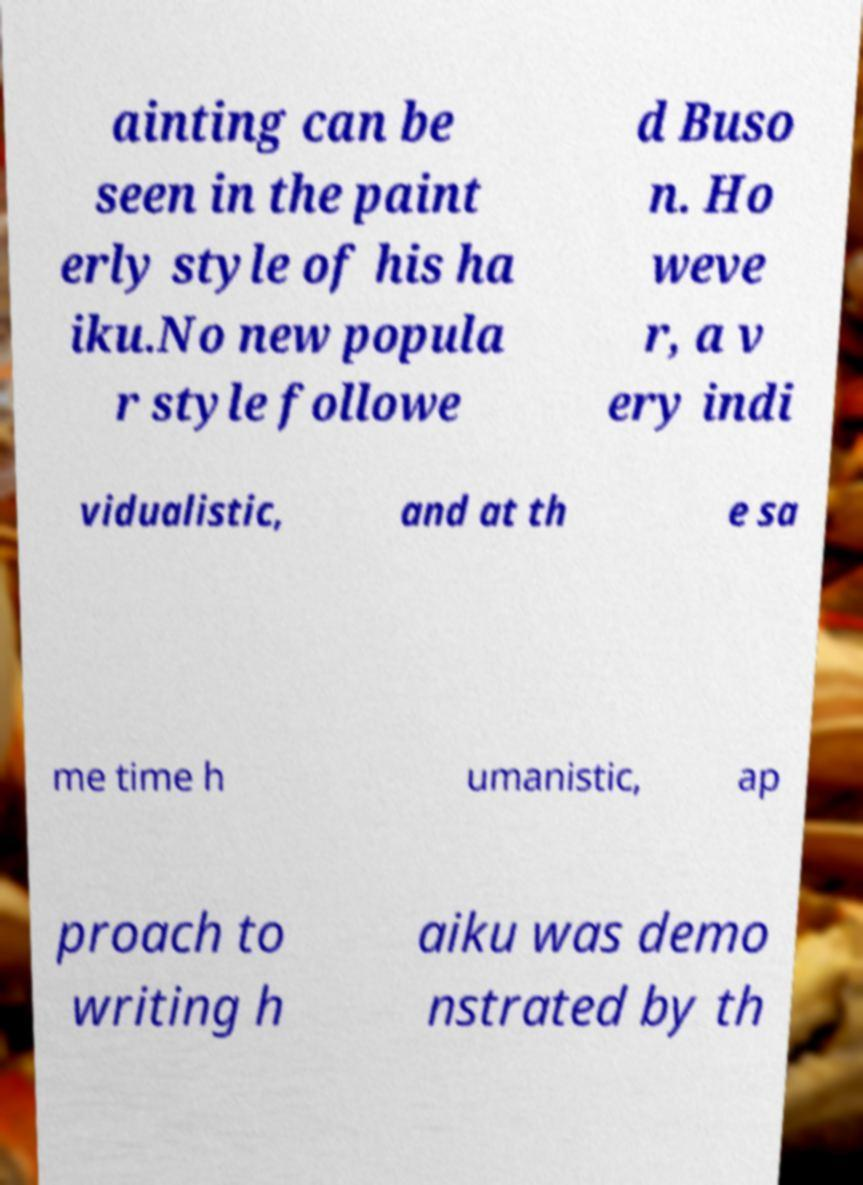For documentation purposes, I need the text within this image transcribed. Could you provide that? ainting can be seen in the paint erly style of his ha iku.No new popula r style followe d Buso n. Ho weve r, a v ery indi vidualistic, and at th e sa me time h umanistic, ap proach to writing h aiku was demo nstrated by th 